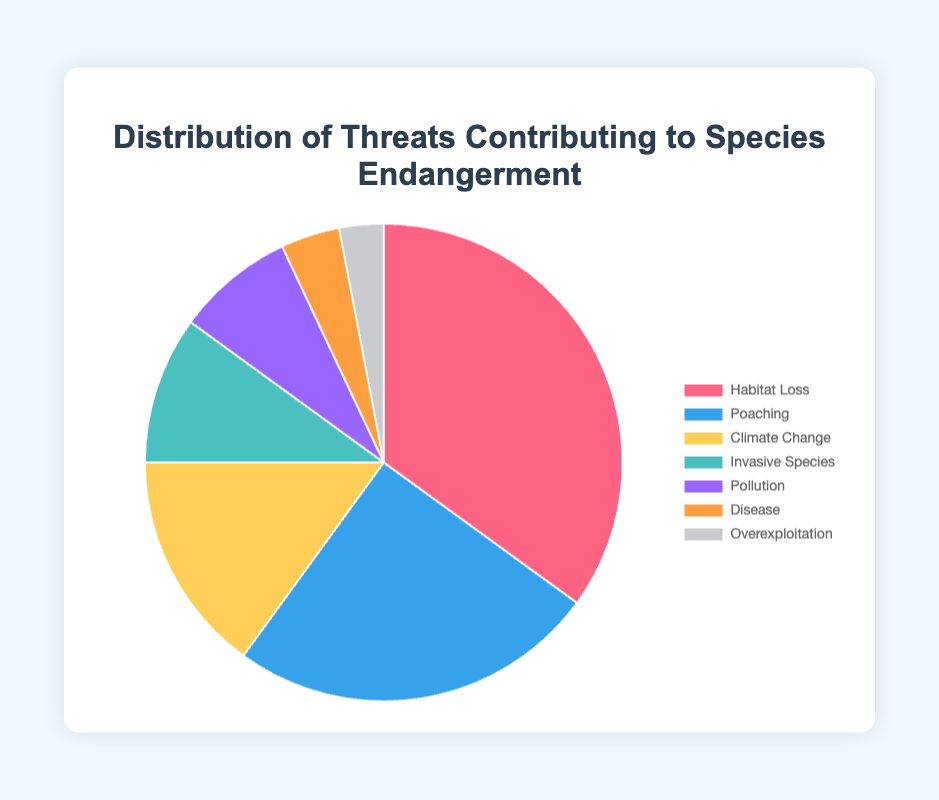Which threat contributes the most to species endangerment? The "Habitat Loss" segment occupies the largest portion of the pie chart. Therefore, it contributes the most.
Answer: Habitat Loss Which two threats together account for 50% of the endangerment causes? Adding the percentages of the top two threats, "Habitat Loss" (35%) and "Poaching" (25%), results in a combined percentage of 60%. However, for exactly 50%, you need "Habitat Loss" (35%) and "Climate Change" (15%).
Answer: Habitat Loss and Climate Change Which threat has a higher percentage: Pollution or Disease? Comparing the two segments, Pollution has a percentage of 8%, while Disease has 4%. Therefore, Pollution has a higher percentage.
Answer: Pollution How do the combined percentages of Invasive Species and Overexploitation compare to that of Climate Change? Invasive Species is 10% and Overexploitation is 3%, yielding a combined 13%. Climate Change is 15%. Thus, the combination is less than Climate Change.
Answer: Less than What is the total percentage contributed by threats other than Habitat Loss? Summing up: Poaching (25%), Climate Change (15%), Invasive Species (10%), Pollution (8%), Disease (4%), Overexploitation (3%) results in 65%.
Answer: 65% Which threat is represented by the green segment? The legend indicates that the green segment corresponds to "Climate Change."
Answer: Climate Change Which threat's percentage is closer to that of Disease: Pollution or Invasive Species? Pollution is 8% and Invasive Species is 10%, while Disease is 4%. The difference between Pollution and Disease is 4%, but between Invasive Species and Disease is 6%, so Pollution is closer.
Answer: Pollution Identify the threat segments that cumulatively make up more than half of the pie chart. Adding the highest percentages from the largest segments first: Habitat Loss (35%), Poaching (25%), these two combined make 60%, which is more than half.
Answer: Habitat Loss and Poaching 